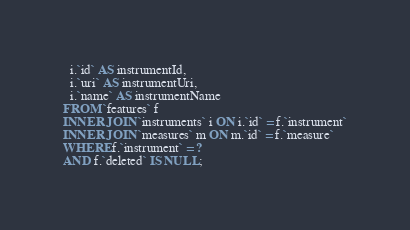<code> <loc_0><loc_0><loc_500><loc_500><_SQL_>  i.`id` AS instrumentId,
  i.`uri` AS instrumentUri,
  i.`name` AS instrumentName
FROM `features` f
INNER JOIN `instruments` i ON i.`id` = f.`instrument`
INNER JOIN `measures` m ON m.`id` = f.`measure`
WHERE f.`instrument` = ? 
AND f.`deleted` IS NULL;</code> 